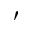Convert formula to latex. <formula><loc_0><loc_0><loc_500><loc_500>^ { \prime }</formula> 